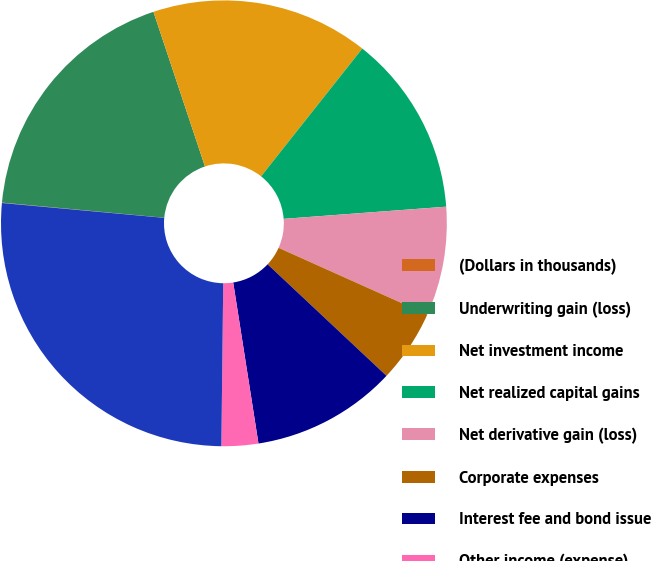Convert chart to OTSL. <chart><loc_0><loc_0><loc_500><loc_500><pie_chart><fcel>(Dollars in thousands)<fcel>Underwriting gain (loss)<fcel>Net investment income<fcel>Net realized capital gains<fcel>Net derivative gain (loss)<fcel>Corporate expenses<fcel>Interest fee and bond issue<fcel>Other income (expense)<fcel>Income (loss) before taxes<nl><fcel>0.03%<fcel>18.4%<fcel>15.78%<fcel>13.15%<fcel>7.9%<fcel>5.28%<fcel>10.53%<fcel>2.66%<fcel>26.27%<nl></chart> 